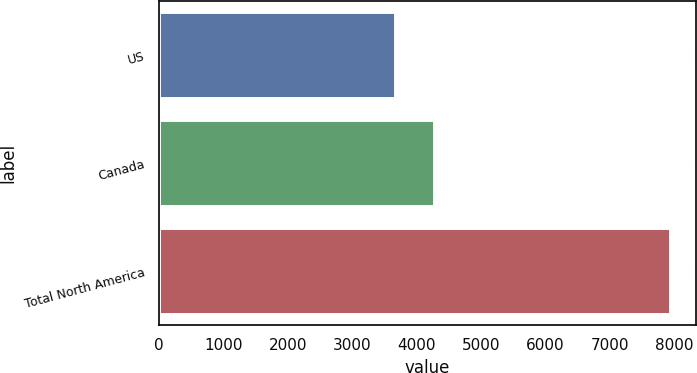Convert chart to OTSL. <chart><loc_0><loc_0><loc_500><loc_500><bar_chart><fcel>US<fcel>Canada<fcel>Total North America<nl><fcel>3669<fcel>4271<fcel>7940<nl></chart> 